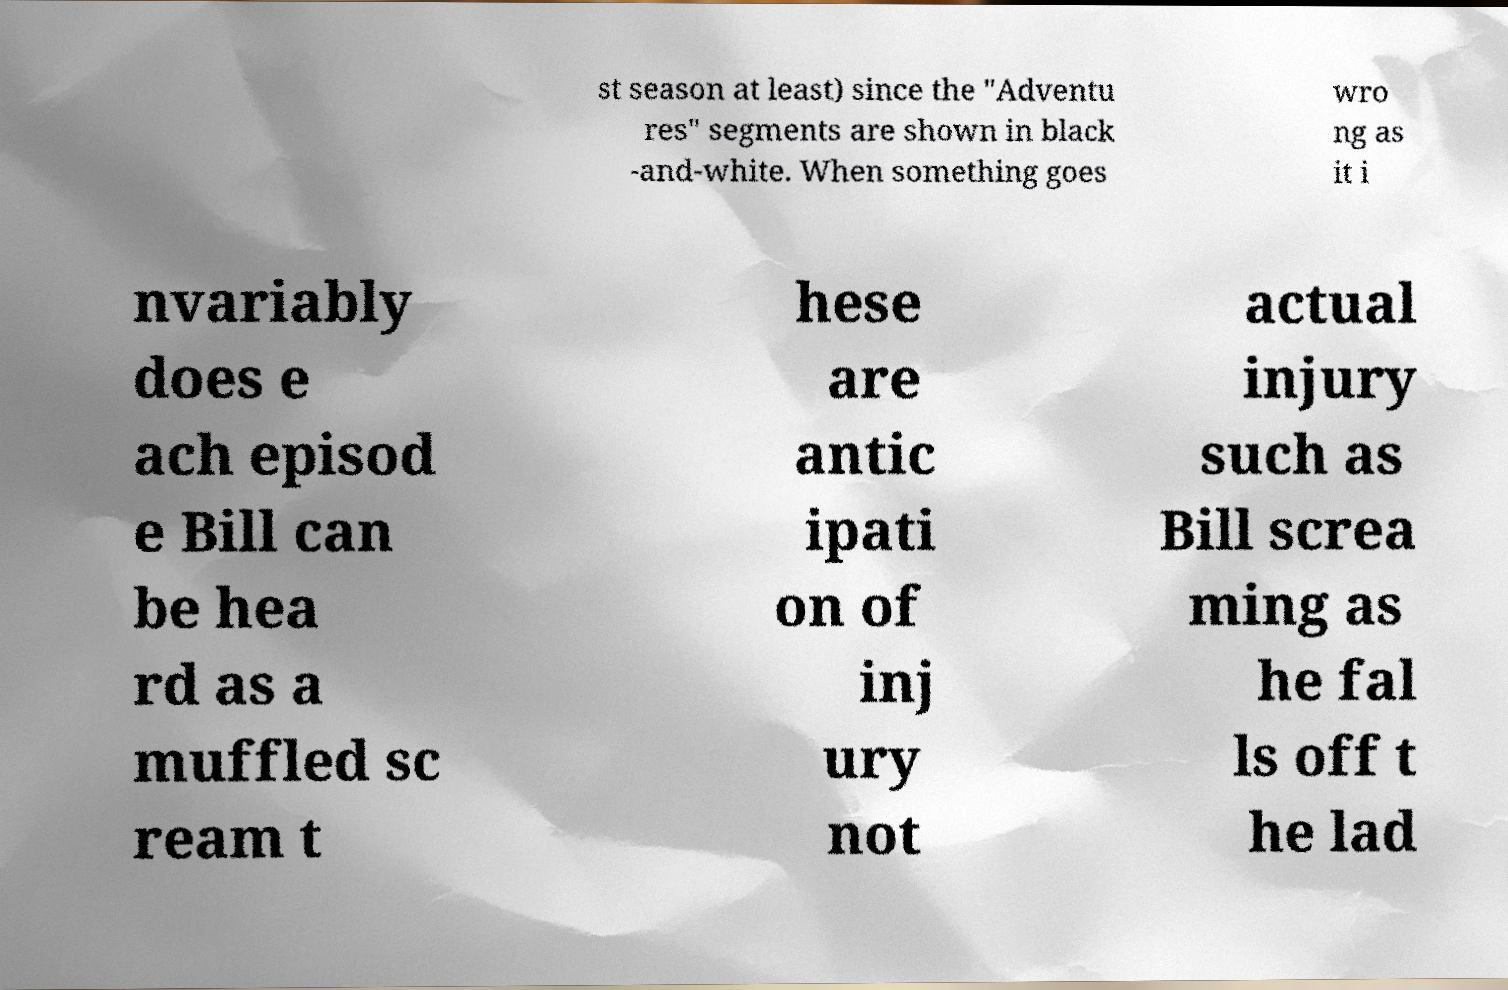For documentation purposes, I need the text within this image transcribed. Could you provide that? st season at least) since the "Adventu res" segments are shown in black -and-white. When something goes wro ng as it i nvariably does e ach episod e Bill can be hea rd as a muffled sc ream t hese are antic ipati on of inj ury not actual injury such as Bill screa ming as he fal ls off t he lad 